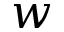<formula> <loc_0><loc_0><loc_500><loc_500>w</formula> 